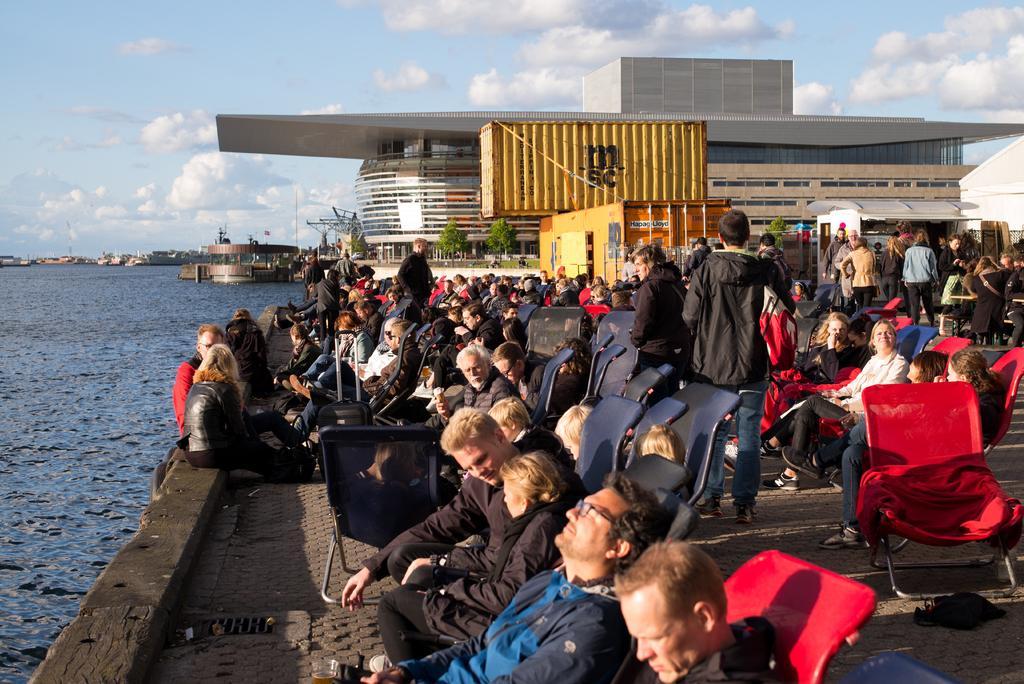In one or two sentences, can you explain what this image depicts? Here we can see a group of people most of them sitting on chairs. There is container and behind that there is building, we can see water here. The sky is full of clouds, yeah we can see a man standing with a backpack. 